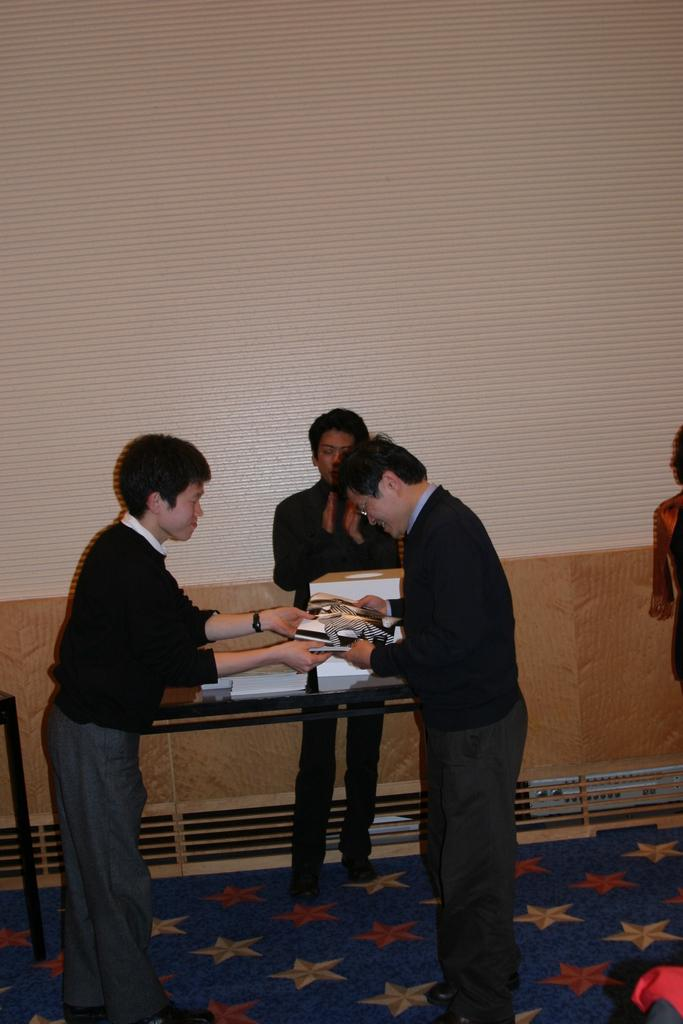How many people are present in the image? There are four people in the image. What is the main object in the image? There is a table in the image. What items can be seen on the table? There are books on the table. What are the people doing with the books? Three of the people are holding books. What type of ice can be seen melting on the table in the image? There is no ice present in the image; it only features people, a table, and books. What amusement park ride can be seen in the background of the image? There is no amusement park ride visible in the image; it is focused on the people, table, and books. 